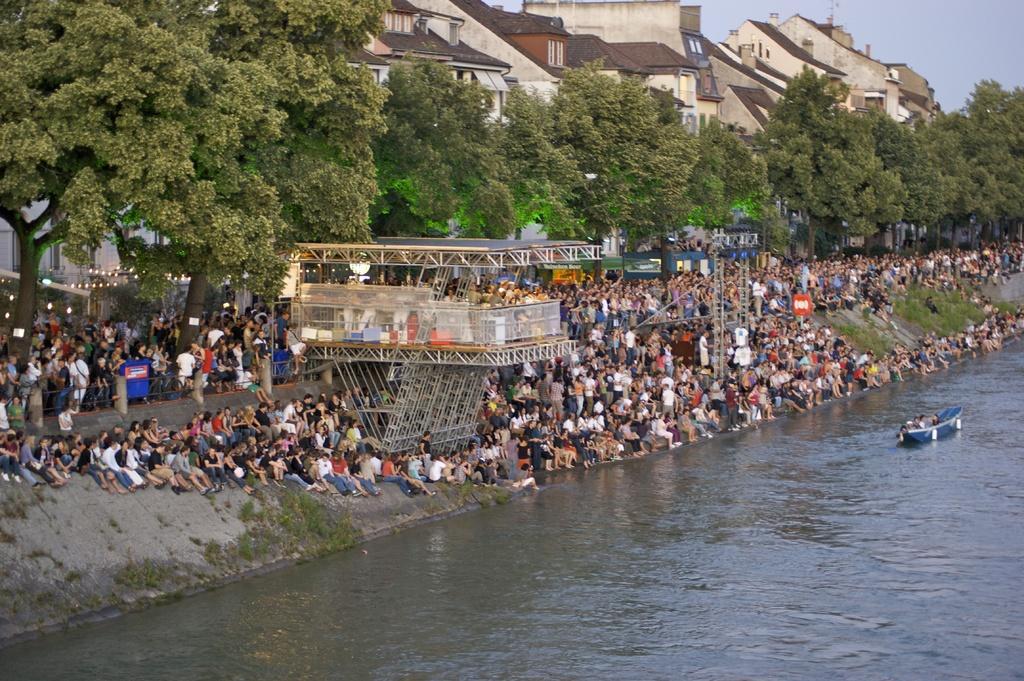In one or two sentences, can you explain what this image depicts? In this picture we can see groups of people and an architecture. Behind the people, there are trees and buildings. In the top right corner of the image, there is the sky. On the right side of the image, there are people in the boat and the boat is on the water. 